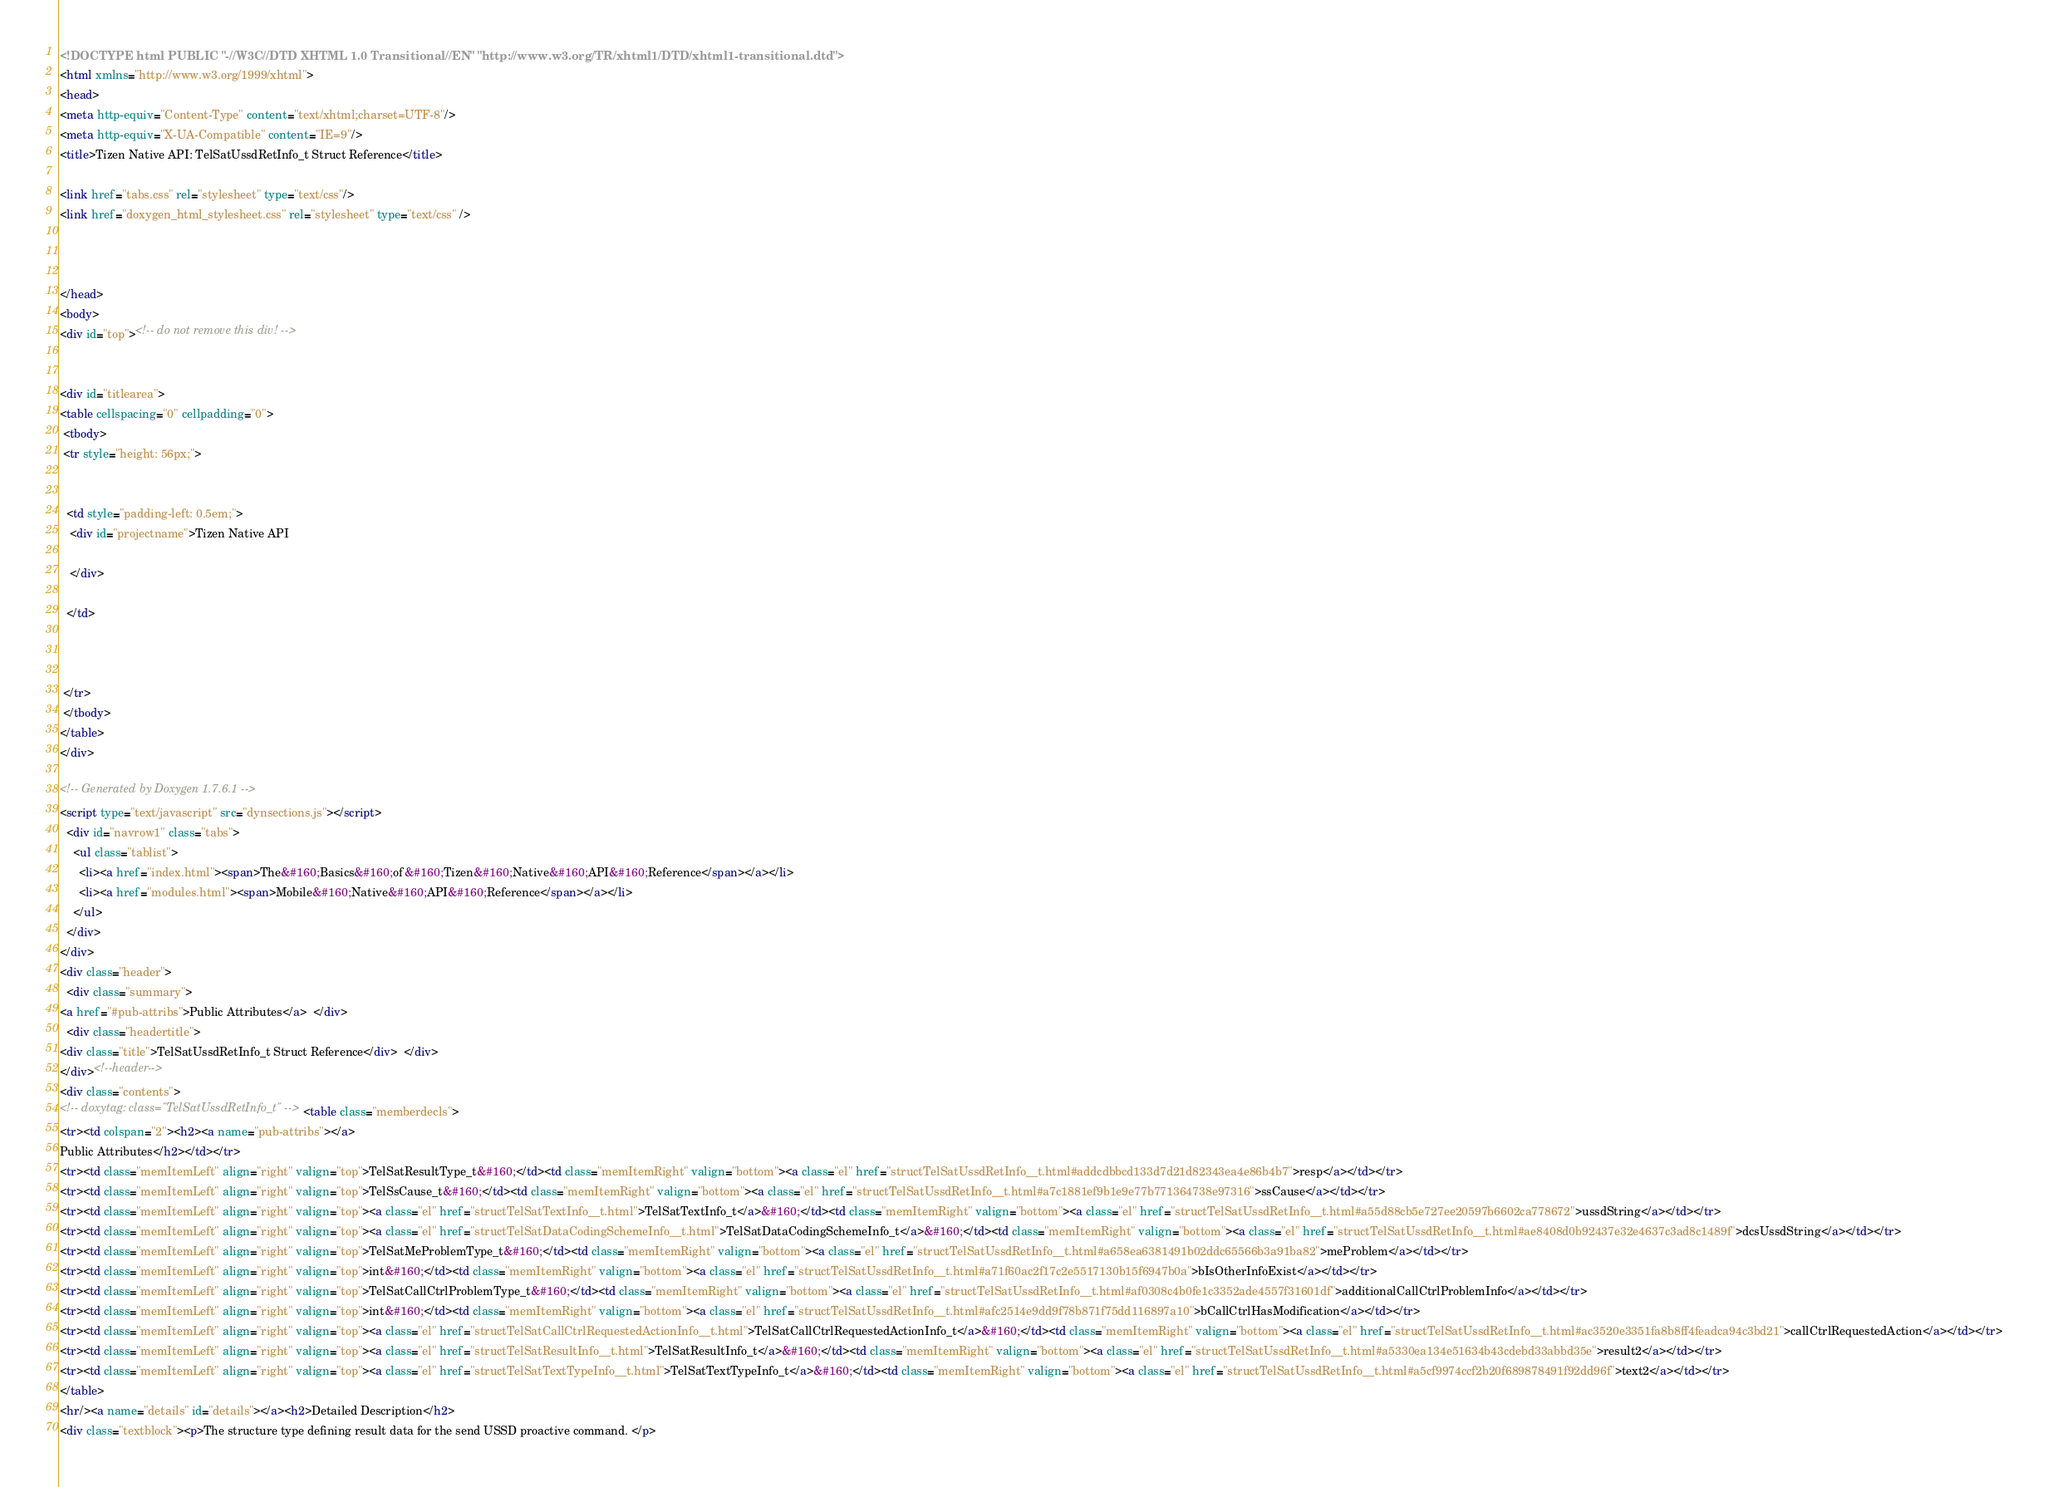<code> <loc_0><loc_0><loc_500><loc_500><_HTML_><!DOCTYPE html PUBLIC "-//W3C//DTD XHTML 1.0 Transitional//EN" "http://www.w3.org/TR/xhtml1/DTD/xhtml1-transitional.dtd">
<html xmlns="http://www.w3.org/1999/xhtml">
<head>
<meta http-equiv="Content-Type" content="text/xhtml;charset=UTF-8"/>
<meta http-equiv="X-UA-Compatible" content="IE=9"/>
<title>Tizen Native API: TelSatUssdRetInfo_t Struct Reference</title>

<link href="tabs.css" rel="stylesheet" type="text/css"/>
<link href="doxygen_html_stylesheet.css" rel="stylesheet" type="text/css" />



</head>
<body>
<div id="top"><!-- do not remove this div! -->


<div id="titlearea">
<table cellspacing="0" cellpadding="0">
 <tbody>
 <tr style="height: 56px;">
  
  
  <td style="padding-left: 0.5em;">
   <div id="projectname">Tizen Native API
   
   </div>
   
  </td>
  
  
  
 </tr>
 </tbody>
</table>
</div>

<!-- Generated by Doxygen 1.7.6.1 -->
<script type="text/javascript" src="dynsections.js"></script>
  <div id="navrow1" class="tabs">
    <ul class="tablist">
      <li><a href="index.html"><span>The&#160;Basics&#160;of&#160;Tizen&#160;Native&#160;API&#160;Reference</span></a></li>
      <li><a href="modules.html"><span>Mobile&#160;Native&#160;API&#160;Reference</span></a></li>
    </ul>
  </div>
</div>
<div class="header">
  <div class="summary">
<a href="#pub-attribs">Public Attributes</a>  </div>
  <div class="headertitle">
<div class="title">TelSatUssdRetInfo_t Struct Reference</div>  </div>
</div><!--header-->
<div class="contents">
<!-- doxytag: class="TelSatUssdRetInfo_t" --><table class="memberdecls">
<tr><td colspan="2"><h2><a name="pub-attribs"></a>
Public Attributes</h2></td></tr>
<tr><td class="memItemLeft" align="right" valign="top">TelSatResultType_t&#160;</td><td class="memItemRight" valign="bottom"><a class="el" href="structTelSatUssdRetInfo__t.html#addcdbbcd133d7d21d82343ea4e86b4b7">resp</a></td></tr>
<tr><td class="memItemLeft" align="right" valign="top">TelSsCause_t&#160;</td><td class="memItemRight" valign="bottom"><a class="el" href="structTelSatUssdRetInfo__t.html#a7c1881ef9b1e9e77b771364738e97316">ssCause</a></td></tr>
<tr><td class="memItemLeft" align="right" valign="top"><a class="el" href="structTelSatTextInfo__t.html">TelSatTextInfo_t</a>&#160;</td><td class="memItemRight" valign="bottom"><a class="el" href="structTelSatUssdRetInfo__t.html#a55d88cb5e727ee20597b6602ca778672">ussdString</a></td></tr>
<tr><td class="memItemLeft" align="right" valign="top"><a class="el" href="structTelSatDataCodingSchemeInfo__t.html">TelSatDataCodingSchemeInfo_t</a>&#160;</td><td class="memItemRight" valign="bottom"><a class="el" href="structTelSatUssdRetInfo__t.html#ae8408d0b92437e32e4637c3ad8c1489f">dcsUssdString</a></td></tr>
<tr><td class="memItemLeft" align="right" valign="top">TelSatMeProblemType_t&#160;</td><td class="memItemRight" valign="bottom"><a class="el" href="structTelSatUssdRetInfo__t.html#a658ea6381491b02ddc65566b3a91ba82">meProblem</a></td></tr>
<tr><td class="memItemLeft" align="right" valign="top">int&#160;</td><td class="memItemRight" valign="bottom"><a class="el" href="structTelSatUssdRetInfo__t.html#a71f60ac2f17c2e5517130b15f6947b0a">bIsOtherInfoExist</a></td></tr>
<tr><td class="memItemLeft" align="right" valign="top">TelSatCallCtrlProblemType_t&#160;</td><td class="memItemRight" valign="bottom"><a class="el" href="structTelSatUssdRetInfo__t.html#af0308c4b0fe1c3352ade4557f31601df">additionalCallCtrlProblemInfo</a></td></tr>
<tr><td class="memItemLeft" align="right" valign="top">int&#160;</td><td class="memItemRight" valign="bottom"><a class="el" href="structTelSatUssdRetInfo__t.html#afc2514e9dd9f78b871f75dd116897a10">bCallCtrlHasModification</a></td></tr>
<tr><td class="memItemLeft" align="right" valign="top"><a class="el" href="structTelSatCallCtrlRequestedActionInfo__t.html">TelSatCallCtrlRequestedActionInfo_t</a>&#160;</td><td class="memItemRight" valign="bottom"><a class="el" href="structTelSatUssdRetInfo__t.html#ac3520e3351fa8b8ff4feadca94c3bd21">callCtrlRequestedAction</a></td></tr>
<tr><td class="memItemLeft" align="right" valign="top"><a class="el" href="structTelSatResultInfo__t.html">TelSatResultInfo_t</a>&#160;</td><td class="memItemRight" valign="bottom"><a class="el" href="structTelSatUssdRetInfo__t.html#a5330ea134e51634b43cdebd33abbd35e">result2</a></td></tr>
<tr><td class="memItemLeft" align="right" valign="top"><a class="el" href="structTelSatTextTypeInfo__t.html">TelSatTextTypeInfo_t</a>&#160;</td><td class="memItemRight" valign="bottom"><a class="el" href="structTelSatUssdRetInfo__t.html#a5cf9974ccf2b20f689878491f92dd96f">text2</a></td></tr>
</table>
<hr/><a name="details" id="details"></a><h2>Detailed Description</h2>
<div class="textblock"><p>The structure type defining result data for the send USSD proactive command. </p></code> 